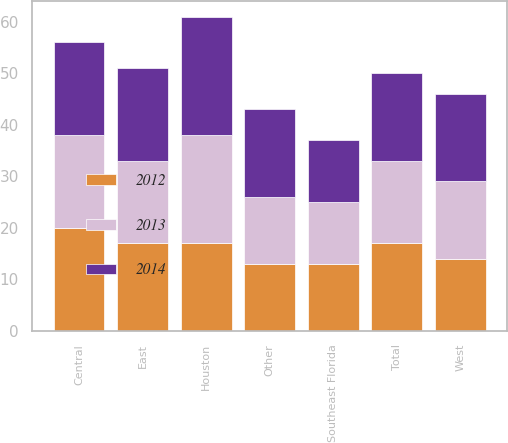Convert chart to OTSL. <chart><loc_0><loc_0><loc_500><loc_500><stacked_bar_chart><ecel><fcel>East<fcel>Central<fcel>West<fcel>Southeast Florida<fcel>Houston<fcel>Other<fcel>Total<nl><fcel>2012<fcel>17<fcel>20<fcel>14<fcel>13<fcel>17<fcel>13<fcel>17<nl><fcel>2013<fcel>16<fcel>18<fcel>15<fcel>12<fcel>21<fcel>13<fcel>16<nl><fcel>2014<fcel>18<fcel>18<fcel>17<fcel>12<fcel>23<fcel>17<fcel>17<nl></chart> 